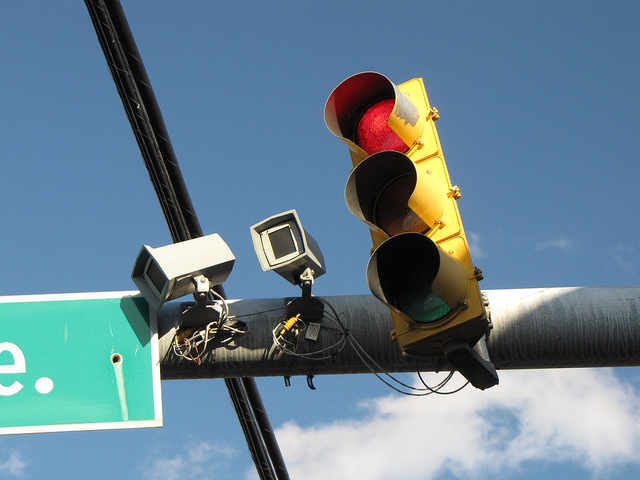How many red lights? 1 